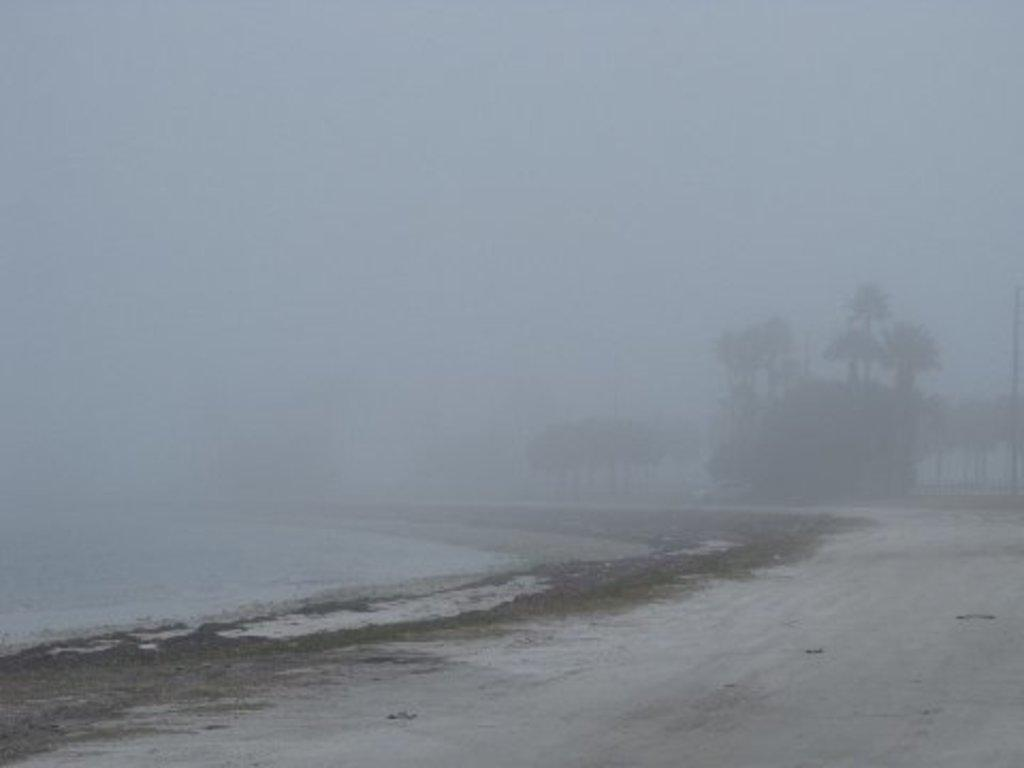What type of terrain is visible in the image? There is ground visible in the image. What natural element is also present in the image? There is water visible in the image. How would you describe the quality of the background in the image? The background of the image is blurry. What type of vegetation can be seen in the background of the image? There are trees visible in the background of the image. What part of the natural environment is visible in the background of the image? The sky is visible in the background of the image. Can you see any dinosaurs walking near the water in the image? There are no dinosaurs present in the image. Is there a bear visible in the background of the image? There is no bear present in the image. 